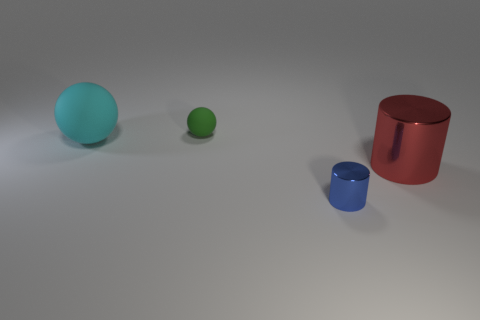Is the number of green matte spheres on the left side of the cyan object less than the number of large red cylinders to the right of the tiny green matte sphere? Yes, there is one green matte sphere to the left of the cyan object, which is indeed less than the one large red cylinder to the right of the tiny green matte sphere. 